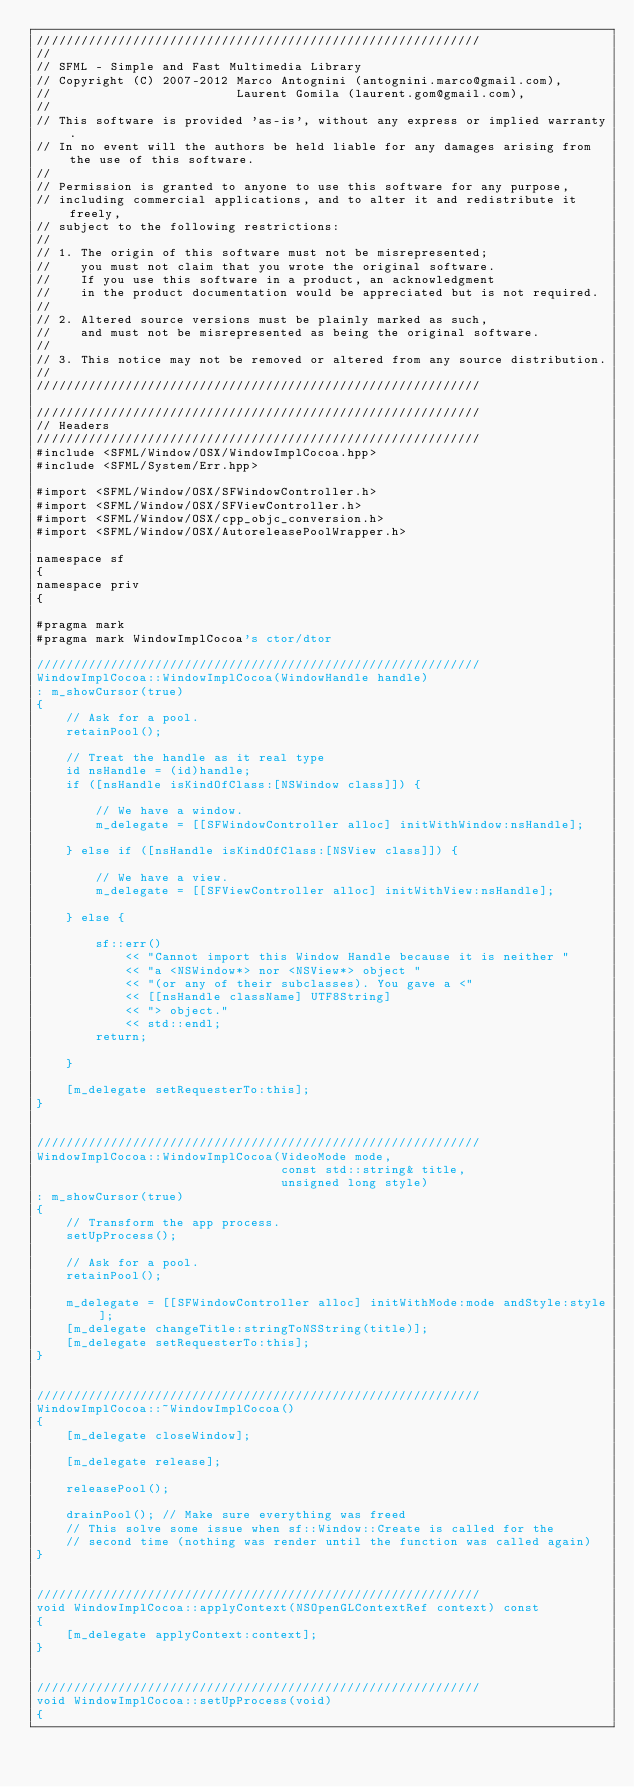Convert code to text. <code><loc_0><loc_0><loc_500><loc_500><_ObjectiveC_>////////////////////////////////////////////////////////////
//
// SFML - Simple and Fast Multimedia Library
// Copyright (C) 2007-2012 Marco Antognini (antognini.marco@gmail.com), 
//                         Laurent Gomila (laurent.gom@gmail.com), 
//
// This software is provided 'as-is', without any express or implied warranty.
// In no event will the authors be held liable for any damages arising from the use of this software.
//
// Permission is granted to anyone to use this software for any purpose,
// including commercial applications, and to alter it and redistribute it freely,
// subject to the following restrictions:
//
// 1. The origin of this software must not be misrepresented;
//    you must not claim that you wrote the original software.
//    If you use this software in a product, an acknowledgment
//    in the product documentation would be appreciated but is not required.
//
// 2. Altered source versions must be plainly marked as such,
//    and must not be misrepresented as being the original software.
//
// 3. This notice may not be removed or altered from any source distribution.
//
////////////////////////////////////////////////////////////

////////////////////////////////////////////////////////////
// Headers
////////////////////////////////////////////////////////////
#include <SFML/Window/OSX/WindowImplCocoa.hpp>
#include <SFML/System/Err.hpp>

#import <SFML/Window/OSX/SFWindowController.h>
#import <SFML/Window/OSX/SFViewController.h>
#import <SFML/Window/OSX/cpp_objc_conversion.h>
#import <SFML/Window/OSX/AutoreleasePoolWrapper.h>

namespace sf
{
namespace priv
{

#pragma mark
#pragma mark WindowImplCocoa's ctor/dtor

////////////////////////////////////////////////////////////
WindowImplCocoa::WindowImplCocoa(WindowHandle handle)
: m_showCursor(true)
{
    // Ask for a pool.
    retainPool();
    
    // Treat the handle as it real type
    id nsHandle = (id)handle;
    if ([nsHandle isKindOfClass:[NSWindow class]]) {
        
        // We have a window.
        m_delegate = [[SFWindowController alloc] initWithWindow:nsHandle];
    
    } else if ([nsHandle isKindOfClass:[NSView class]]) {
        
        // We have a view.
        m_delegate = [[SFViewController alloc] initWithView:nsHandle];
        
    } else {
        
        sf::err()
            << "Cannot import this Window Handle because it is neither "
            << "a <NSWindow*> nor <NSView*> object "
            << "(or any of their subclasses). You gave a <" 
            << [[nsHandle className] UTF8String]
            << "> object."
            << std::endl;
        return;            
        
    }
     
    [m_delegate setRequesterTo:this];
}
    
    
////////////////////////////////////////////////////////////
WindowImplCocoa::WindowImplCocoa(VideoMode mode, 
                                 const std::string& title, 
                                 unsigned long style)
: m_showCursor(true)
{
    // Transform the app process.
    setUpProcess();
    
    // Ask for a pool.
    retainPool();
    
    m_delegate = [[SFWindowController alloc] initWithMode:mode andStyle:style];
    [m_delegate changeTitle:stringToNSString(title)];
    [m_delegate setRequesterTo:this];
}

    
////////////////////////////////////////////////////////////
WindowImplCocoa::~WindowImplCocoa()
{
    [m_delegate closeWindow];
    
    [m_delegate release];
    
    releasePool();
    
    drainPool(); // Make sure everything was freed
    // This solve some issue when sf::Window::Create is called for the
    // second time (nothing was render until the function was called again)
}
    
    
////////////////////////////////////////////////////////////
void WindowImplCocoa::applyContext(NSOpenGLContextRef context) const
{
    [m_delegate applyContext:context];
}


////////////////////////////////////////////////////////////
void WindowImplCocoa::setUpProcess(void)
{</code> 